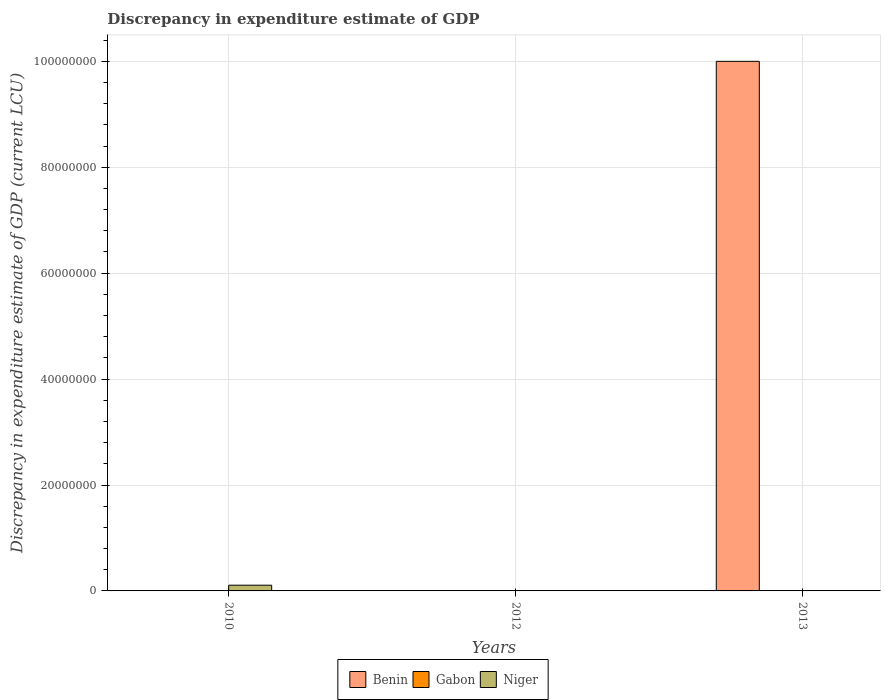What is the discrepancy in expenditure estimate of GDP in Niger in 2010?
Provide a succinct answer. 1.08e+06. In which year was the discrepancy in expenditure estimate of GDP in Benin maximum?
Offer a very short reply. 2013. What is the total discrepancy in expenditure estimate of GDP in Gabon in the graph?
Your answer should be compact. 0. What is the difference between the discrepancy in expenditure estimate of GDP in Niger in 2010 and that in 2012?
Provide a succinct answer. 1.08e+06. What is the difference between the discrepancy in expenditure estimate of GDP in Gabon in 2010 and the discrepancy in expenditure estimate of GDP in Benin in 2013?
Your answer should be very brief. -1.00e+08. What is the average discrepancy in expenditure estimate of GDP in Niger per year?
Ensure brevity in your answer.  3.60e+05. In the year 2012, what is the difference between the discrepancy in expenditure estimate of GDP in Gabon and discrepancy in expenditure estimate of GDP in Niger?
Ensure brevity in your answer.  0. What is the ratio of the discrepancy in expenditure estimate of GDP in Niger in 2010 to that in 2012?
Your answer should be compact. 1.54e+09. Is the discrepancy in expenditure estimate of GDP in Niger in 2010 less than that in 2013?
Offer a terse response. No. What is the difference between the highest and the second highest discrepancy in expenditure estimate of GDP in Niger?
Provide a succinct answer. 1.08e+06. In how many years, is the discrepancy in expenditure estimate of GDP in Niger greater than the average discrepancy in expenditure estimate of GDP in Niger taken over all years?
Keep it short and to the point. 1. Is the sum of the discrepancy in expenditure estimate of GDP in Niger in 2012 and 2013 greater than the maximum discrepancy in expenditure estimate of GDP in Benin across all years?
Offer a terse response. No. How many bars are there?
Provide a short and direct response. 5. Are the values on the major ticks of Y-axis written in scientific E-notation?
Keep it short and to the point. No. How many legend labels are there?
Provide a short and direct response. 3. What is the title of the graph?
Your answer should be compact. Discrepancy in expenditure estimate of GDP. What is the label or title of the X-axis?
Offer a very short reply. Years. What is the label or title of the Y-axis?
Provide a short and direct response. Discrepancy in expenditure estimate of GDP (current LCU). What is the Discrepancy in expenditure estimate of GDP (current LCU) of Gabon in 2010?
Ensure brevity in your answer.  0. What is the Discrepancy in expenditure estimate of GDP (current LCU) of Niger in 2010?
Ensure brevity in your answer.  1.08e+06. What is the Discrepancy in expenditure estimate of GDP (current LCU) in Gabon in 2012?
Give a very brief answer. 0. What is the Discrepancy in expenditure estimate of GDP (current LCU) in Niger in 2012?
Ensure brevity in your answer.  0. What is the Discrepancy in expenditure estimate of GDP (current LCU) in Benin in 2013?
Your answer should be compact. 1.00e+08. What is the Discrepancy in expenditure estimate of GDP (current LCU) in Gabon in 2013?
Your answer should be compact. 0. What is the Discrepancy in expenditure estimate of GDP (current LCU) of Niger in 2013?
Offer a very short reply. 0. Across all years, what is the maximum Discrepancy in expenditure estimate of GDP (current LCU) of Benin?
Your response must be concise. 1.00e+08. Across all years, what is the maximum Discrepancy in expenditure estimate of GDP (current LCU) in Gabon?
Give a very brief answer. 0. Across all years, what is the maximum Discrepancy in expenditure estimate of GDP (current LCU) of Niger?
Keep it short and to the point. 1.08e+06. Across all years, what is the minimum Discrepancy in expenditure estimate of GDP (current LCU) of Benin?
Offer a terse response. 0. What is the total Discrepancy in expenditure estimate of GDP (current LCU) in Benin in the graph?
Ensure brevity in your answer.  1.00e+08. What is the total Discrepancy in expenditure estimate of GDP (current LCU) of Gabon in the graph?
Provide a short and direct response. 0. What is the total Discrepancy in expenditure estimate of GDP (current LCU) in Niger in the graph?
Make the answer very short. 1.08e+06. What is the difference between the Discrepancy in expenditure estimate of GDP (current LCU) of Niger in 2010 and that in 2012?
Provide a succinct answer. 1.08e+06. What is the difference between the Discrepancy in expenditure estimate of GDP (current LCU) in Niger in 2010 and that in 2013?
Provide a short and direct response. 1.08e+06. What is the difference between the Discrepancy in expenditure estimate of GDP (current LCU) in Gabon in 2012 and the Discrepancy in expenditure estimate of GDP (current LCU) in Niger in 2013?
Keep it short and to the point. 0. What is the average Discrepancy in expenditure estimate of GDP (current LCU) of Benin per year?
Your answer should be compact. 3.33e+07. What is the average Discrepancy in expenditure estimate of GDP (current LCU) in Gabon per year?
Your answer should be very brief. 0. What is the average Discrepancy in expenditure estimate of GDP (current LCU) in Niger per year?
Provide a short and direct response. 3.60e+05. In the year 2013, what is the difference between the Discrepancy in expenditure estimate of GDP (current LCU) of Benin and Discrepancy in expenditure estimate of GDP (current LCU) of Niger?
Your answer should be compact. 1.00e+08. What is the ratio of the Discrepancy in expenditure estimate of GDP (current LCU) in Niger in 2010 to that in 2012?
Keep it short and to the point. 1.54e+09. What is the ratio of the Discrepancy in expenditure estimate of GDP (current LCU) of Niger in 2010 to that in 2013?
Ensure brevity in your answer.  5.40e+09. What is the difference between the highest and the second highest Discrepancy in expenditure estimate of GDP (current LCU) in Niger?
Keep it short and to the point. 1.08e+06. What is the difference between the highest and the lowest Discrepancy in expenditure estimate of GDP (current LCU) of Gabon?
Ensure brevity in your answer.  0. What is the difference between the highest and the lowest Discrepancy in expenditure estimate of GDP (current LCU) in Niger?
Provide a succinct answer. 1.08e+06. 